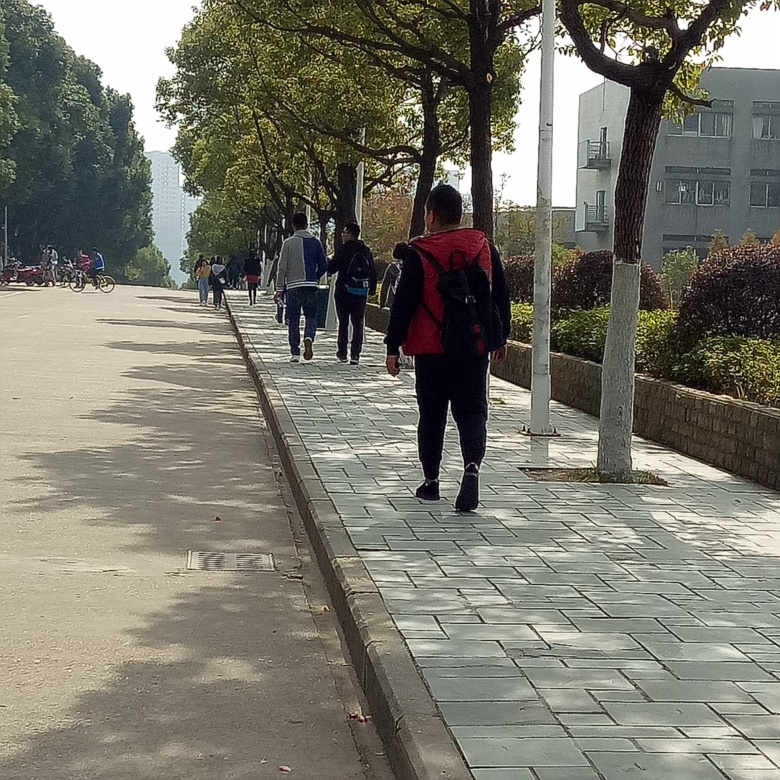What time of year does this photo appear to have been taken? The photo appears to have been taken during a season with moderate weather, likely spring or fall, as the trees are full of leaves and people are dressed in light to medium layers of clothing. 